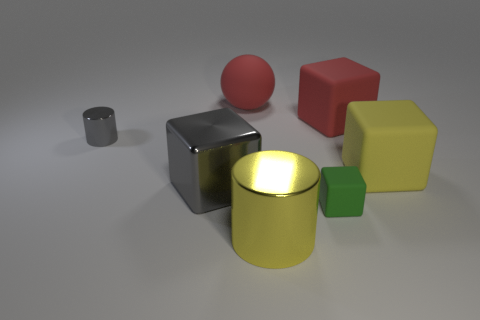What color is the large object that is both on the left side of the tiny green rubber block and behind the gray metal cube?
Keep it short and to the point. Red. There is a metallic cylinder that is behind the green object that is in front of the rubber ball; what size is it?
Provide a succinct answer. Small. Are there any tiny objects that have the same color as the shiny block?
Offer a terse response. Yes. Are there the same number of red matte blocks that are to the left of the large shiny cylinder and cyan shiny blocks?
Provide a succinct answer. Yes. How many green cylinders are there?
Offer a terse response. 0. What shape is the large thing that is both to the right of the gray metal cube and in front of the large yellow cube?
Your answer should be very brief. Cylinder. There is a large object to the right of the red cube; is it the same color as the metallic cylinder in front of the small green thing?
Keep it short and to the point. Yes. What is the size of the shiny thing that is the same color as the small cylinder?
Your answer should be compact. Large. Is there a block that has the same material as the tiny gray cylinder?
Your response must be concise. Yes. Are there the same number of red rubber spheres that are to the right of the big yellow shiny cylinder and big cubes behind the tiny metallic cylinder?
Make the answer very short. No. 